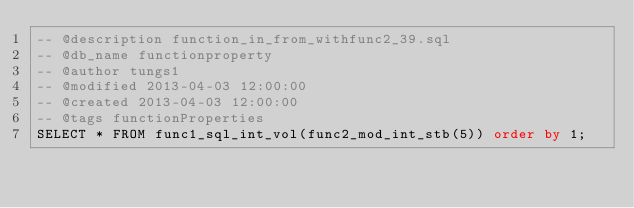<code> <loc_0><loc_0><loc_500><loc_500><_SQL_>-- @description function_in_from_withfunc2_39.sql
-- @db_name functionproperty
-- @author tungs1
-- @modified 2013-04-03 12:00:00
-- @created 2013-04-03 12:00:00
-- @tags functionProperties 
SELECT * FROM func1_sql_int_vol(func2_mod_int_stb(5)) order by 1; 
</code> 